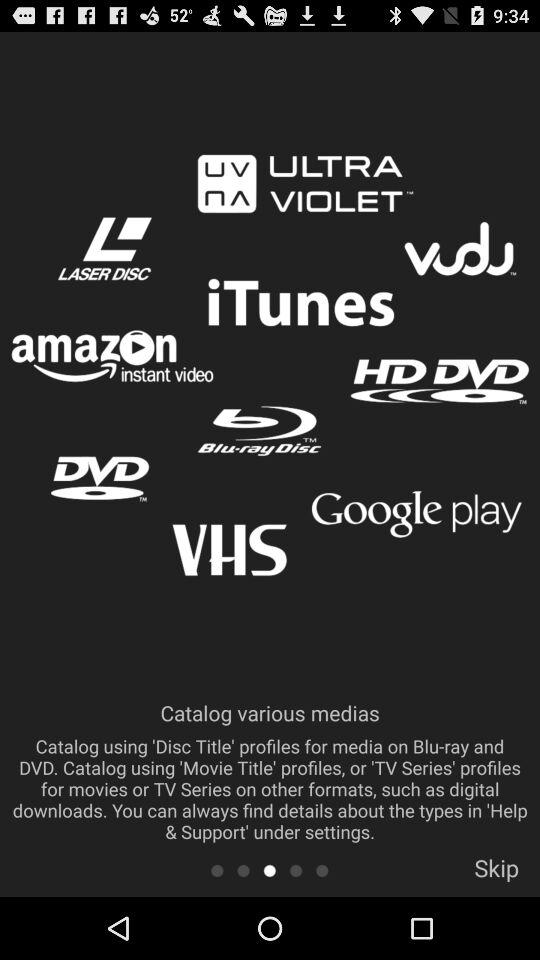How many media providers have a logo?
Answer the question using a single word or phrase. 6 